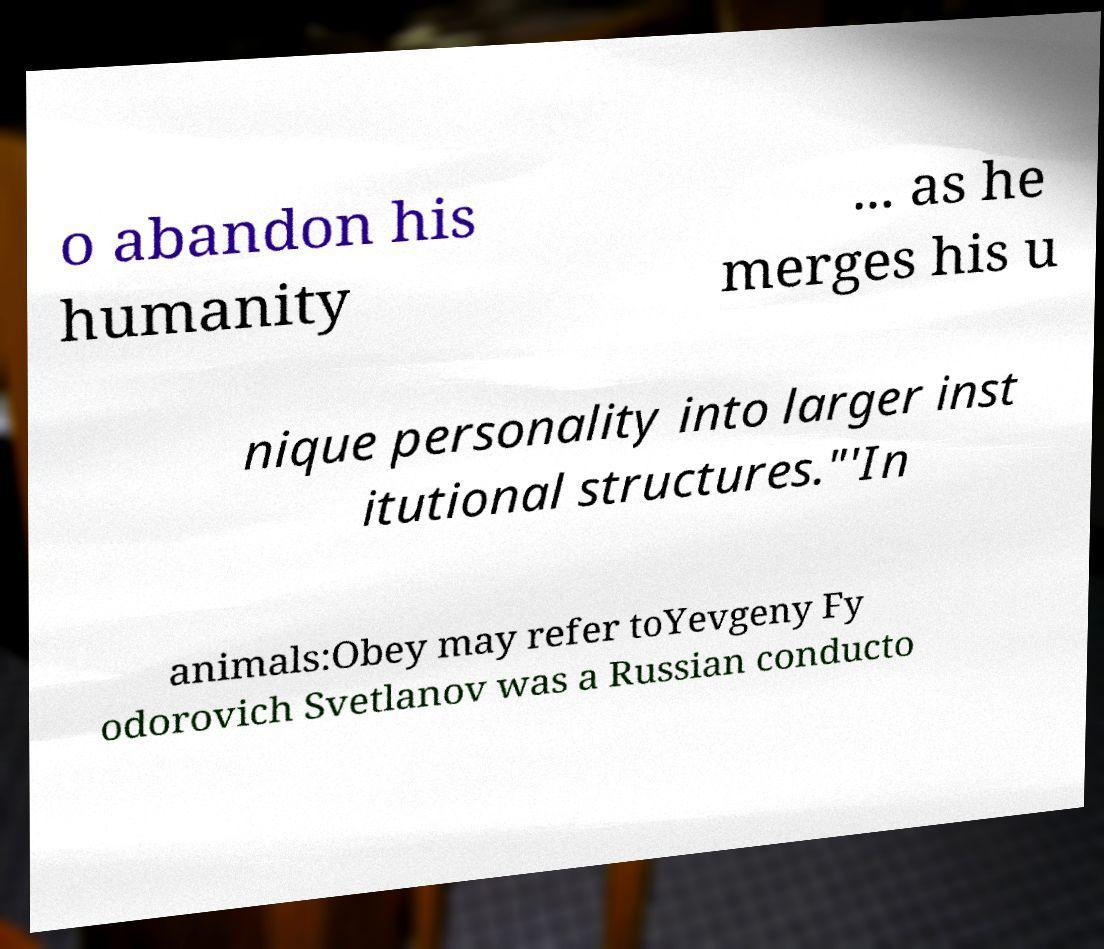Could you extract and type out the text from this image? o abandon his humanity ... as he merges his u nique personality into larger inst itutional structures."'In animals:Obey may refer toYevgeny Fy odorovich Svetlanov was a Russian conducto 